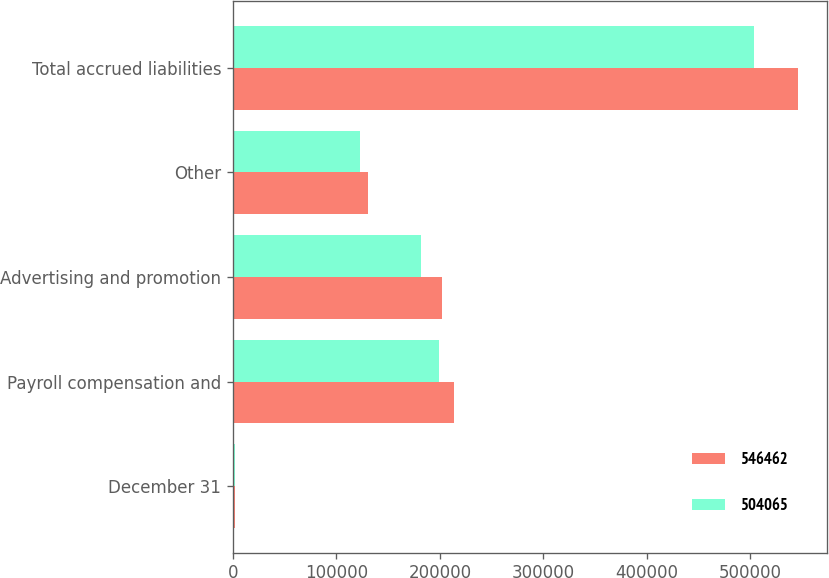Convert chart. <chart><loc_0><loc_0><loc_500><loc_500><stacked_bar_chart><ecel><fcel>December 31<fcel>Payroll compensation and<fcel>Advertising and promotion<fcel>Other<fcel>Total accrued liabilities<nl><fcel>546462<fcel>2009<fcel>213715<fcel>202547<fcel>130200<fcel>546462<nl><fcel>504065<fcel>2008<fcel>198710<fcel>182227<fcel>123128<fcel>504065<nl></chart> 